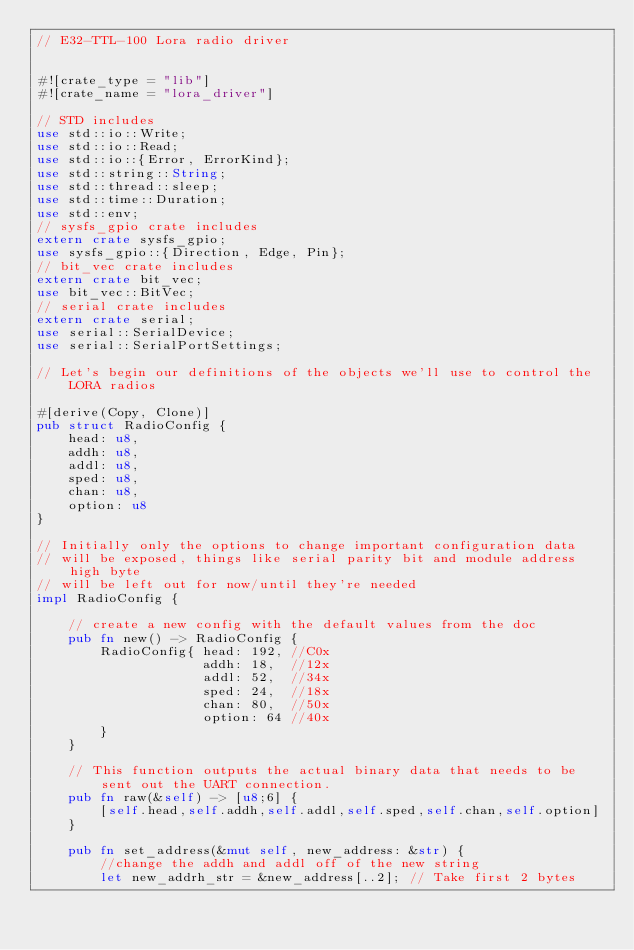<code> <loc_0><loc_0><loc_500><loc_500><_Rust_>// E32-TTL-100 Lora radio driver


#![crate_type = "lib"]
#![crate_name = "lora_driver"]

// STD includes
use std::io::Write;
use std::io::Read;
use std::io::{Error, ErrorKind};
use std::string::String;
use std::thread::sleep;
use std::time::Duration;
use std::env;
// sysfs_gpio crate includes
extern crate sysfs_gpio;
use sysfs_gpio::{Direction, Edge, Pin};
// bit_vec crate includes
extern crate bit_vec;
use bit_vec::BitVec;
// serial crate includes
extern crate serial;
use serial::SerialDevice;
use serial::SerialPortSettings;

// Let's begin our definitions of the objects we'll use to control the LORA radios

#[derive(Copy, Clone)]
pub struct RadioConfig {
	head: u8,
	addh: u8,
	addl: u8,
	sped: u8,
	chan: u8,
	option: u8
}

// Initially only the options to change important configuration data
// will be exposed, things like serial parity bit and module address high byte
// will be left out for now/until they're needed
impl RadioConfig {

	// create a new config with the default values from the doc
	pub fn new() -> RadioConfig {
		RadioConfig{ head: 192,	//C0x
					 addh: 18,	//12x
					 addl: 52,	//34x
					 sped: 24,	//18x
					 chan: 80,	//50x
					 option: 64	//40x
		}
	}

	// This function outputs the actual binary data that needs to be sent out the UART connection.
	pub fn raw(&self) -> [u8;6] {
		[self.head,self.addh,self.addl,self.sped,self.chan,self.option]
	}

	pub fn set_address(&mut self, new_address: &str) {
		//change the addh and addl off of the new string
		let new_addrh_str = &new_address[..2]; // Take first 2 bytes</code> 